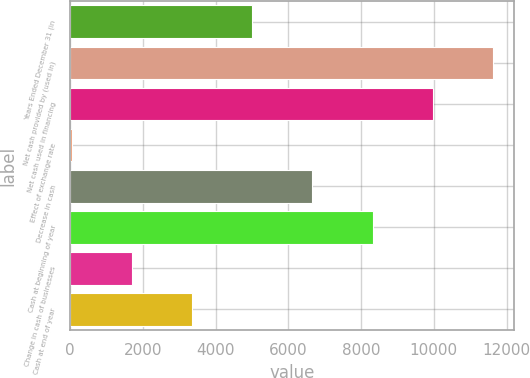<chart> <loc_0><loc_0><loc_500><loc_500><bar_chart><fcel>Years Ended December 31 (in<fcel>Net cash provided by (used in)<fcel>Net cash used in financing<fcel>Effect of exchange rate<fcel>Decrease in cash<fcel>Cash at beginning of year<fcel>Change in cash of businesses<fcel>Cash at end of year<nl><fcel>5006.4<fcel>11629.6<fcel>9973.8<fcel>39<fcel>6662.2<fcel>8318<fcel>1694.8<fcel>3350.6<nl></chart> 